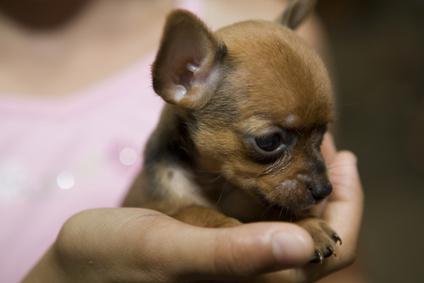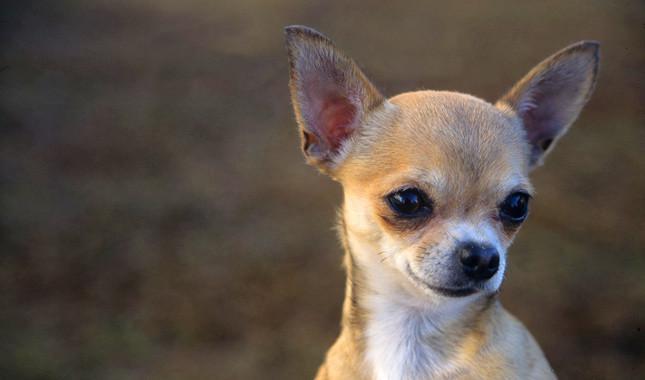The first image is the image on the left, the second image is the image on the right. Assess this claim about the two images: "the dog on the right image has its mouth open". Correct or not? Answer yes or no. No. 